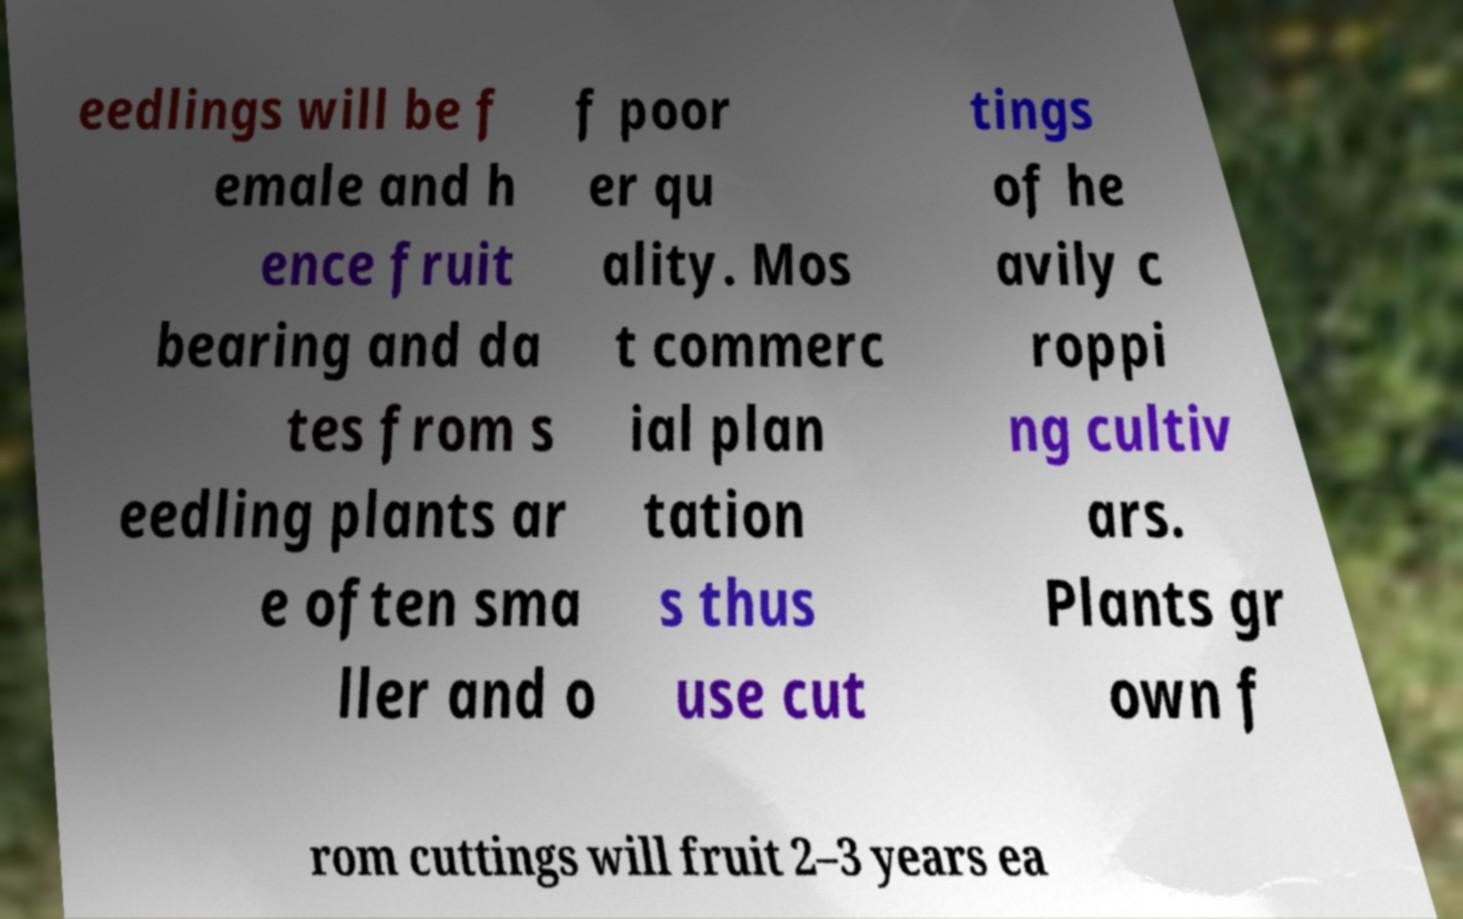Could you extract and type out the text from this image? eedlings will be f emale and h ence fruit bearing and da tes from s eedling plants ar e often sma ller and o f poor er qu ality. Mos t commerc ial plan tation s thus use cut tings of he avily c roppi ng cultiv ars. Plants gr own f rom cuttings will fruit 2–3 years ea 